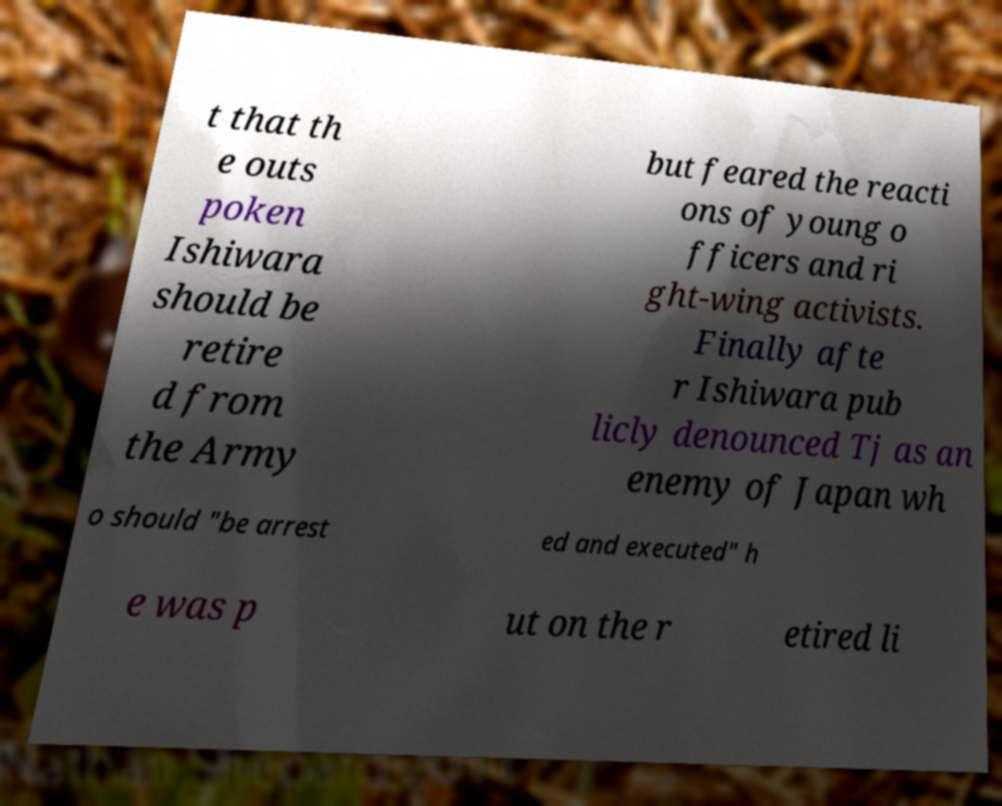Can you accurately transcribe the text from the provided image for me? t that th e outs poken Ishiwara should be retire d from the Army but feared the reacti ons of young o fficers and ri ght-wing activists. Finally afte r Ishiwara pub licly denounced Tj as an enemy of Japan wh o should "be arrest ed and executed" h e was p ut on the r etired li 